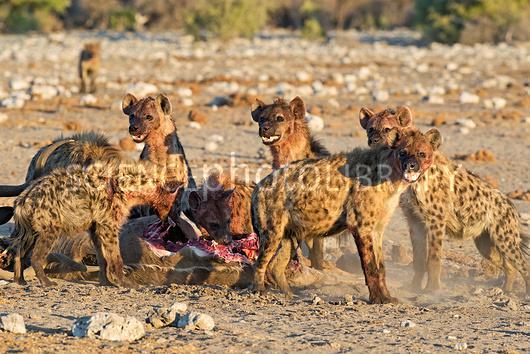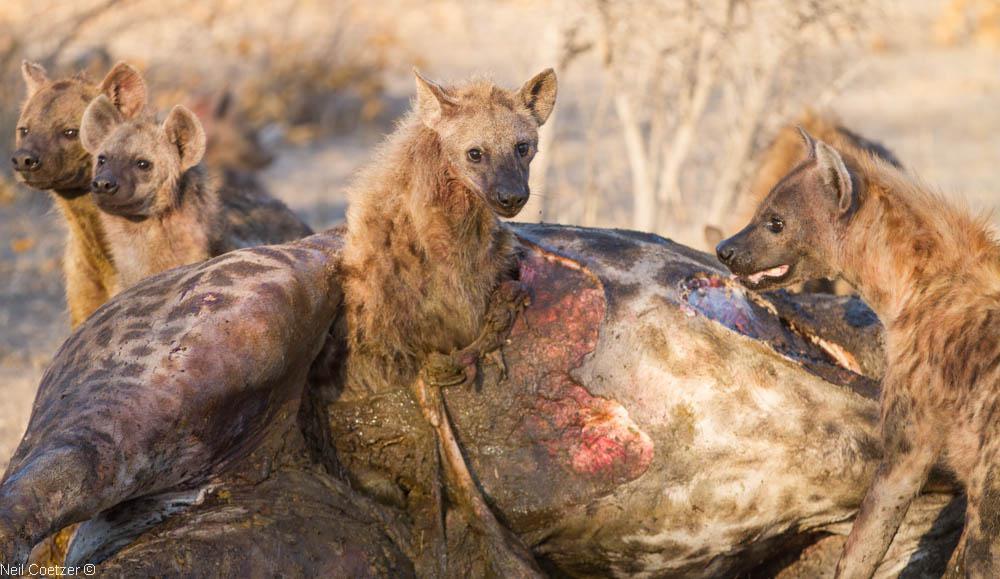The first image is the image on the left, the second image is the image on the right. Given the left and right images, does the statement "In the image to the right, there are at least four hyenas." hold true? Answer yes or no. Yes. The first image is the image on the left, the second image is the image on the right. For the images displayed, is the sentence "Multiple hyena are standing behind a carcass with the horn of a hooved animal in front of them, including a leftward-turned hyena with its mouth lowered to the carcass." factually correct? Answer yes or no. No. 